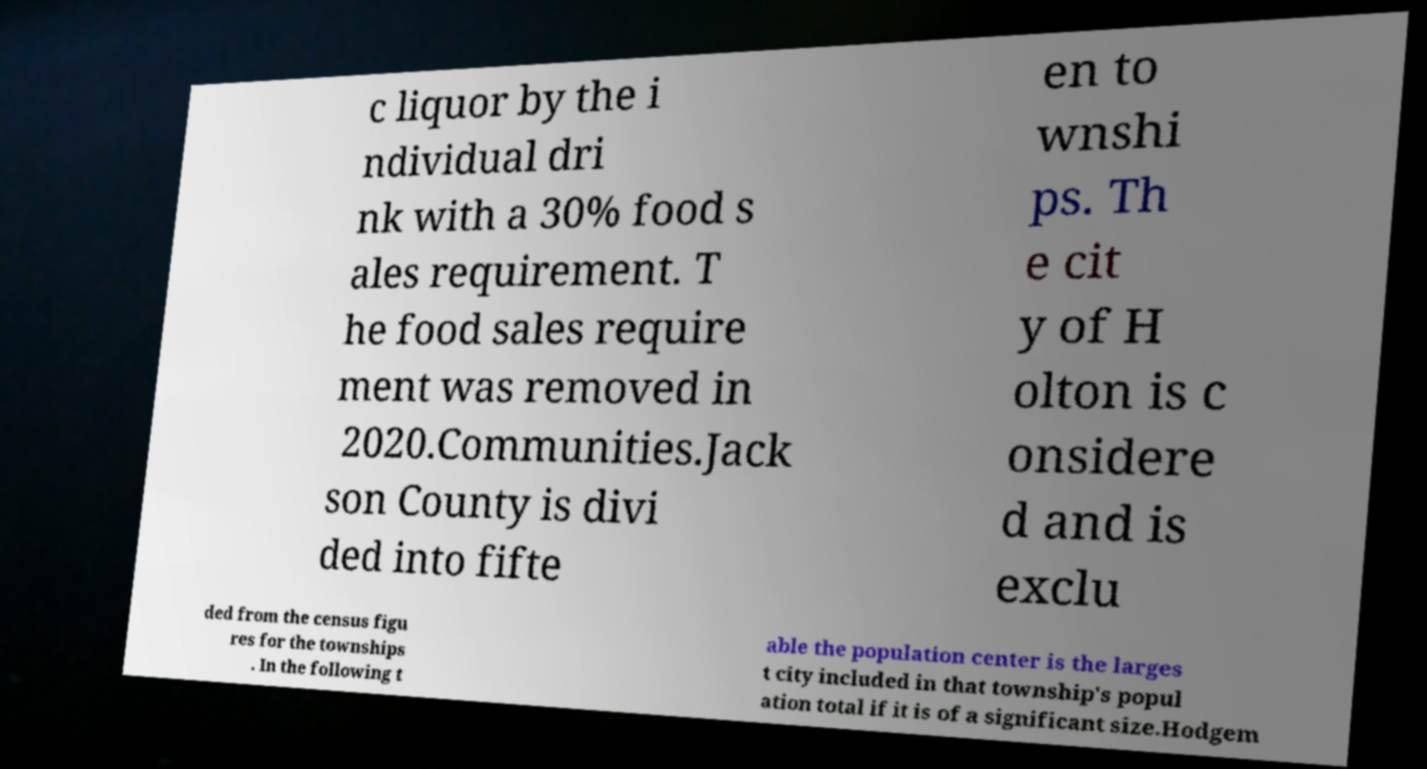Could you extract and type out the text from this image? c liquor by the i ndividual dri nk with a 30% food s ales requirement. T he food sales require ment was removed in 2020.Communities.Jack son County is divi ded into fifte en to wnshi ps. Th e cit y of H olton is c onsidere d and is exclu ded from the census figu res for the townships . In the following t able the population center is the larges t city included in that township's popul ation total if it is of a significant size.Hodgem 